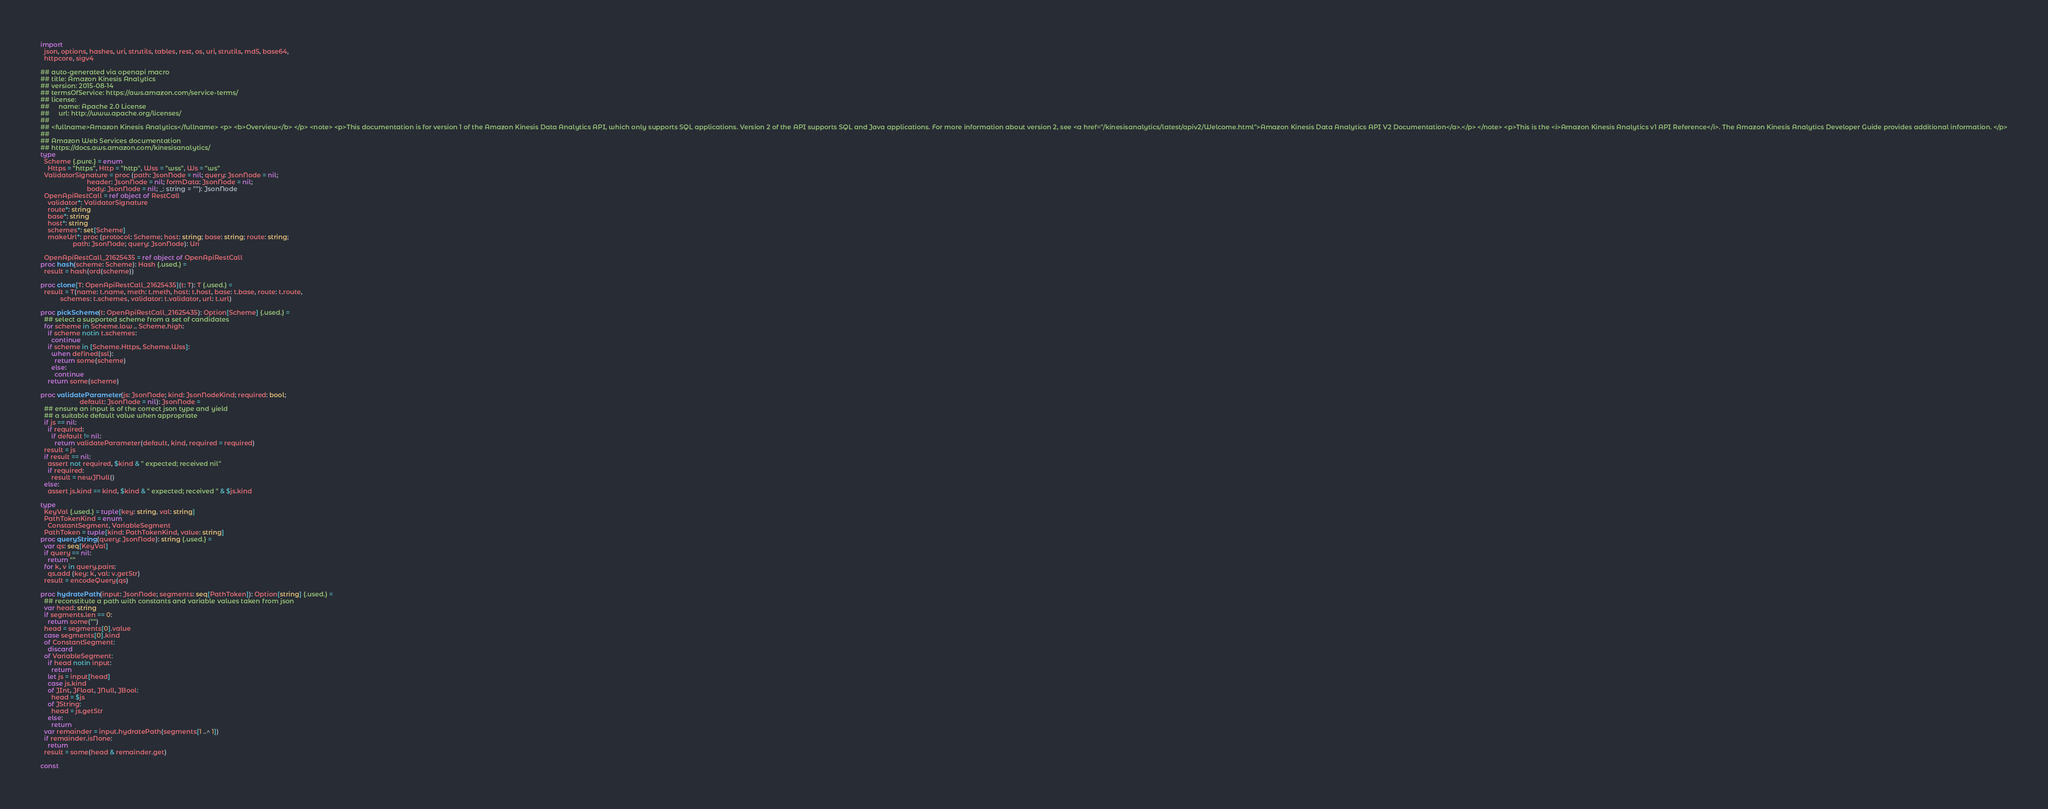Convert code to text. <code><loc_0><loc_0><loc_500><loc_500><_Nim_>
import
  json, options, hashes, uri, strutils, tables, rest, os, uri, strutils, md5, base64,
  httpcore, sigv4

## auto-generated via openapi macro
## title: Amazon Kinesis Analytics
## version: 2015-08-14
## termsOfService: https://aws.amazon.com/service-terms/
## license:
##     name: Apache 2.0 License
##     url: http://www.apache.org/licenses/
## 
## <fullname>Amazon Kinesis Analytics</fullname> <p> <b>Overview</b> </p> <note> <p>This documentation is for version 1 of the Amazon Kinesis Data Analytics API, which only supports SQL applications. Version 2 of the API supports SQL and Java applications. For more information about version 2, see <a href="/kinesisanalytics/latest/apiv2/Welcome.html">Amazon Kinesis Data Analytics API V2 Documentation</a>.</p> </note> <p>This is the <i>Amazon Kinesis Analytics v1 API Reference</i>. The Amazon Kinesis Analytics Developer Guide provides additional information. </p>
## 
## Amazon Web Services documentation
## https://docs.aws.amazon.com/kinesisanalytics/
type
  Scheme {.pure.} = enum
    Https = "https", Http = "http", Wss = "wss", Ws = "ws"
  ValidatorSignature = proc (path: JsonNode = nil; query: JsonNode = nil;
                          header: JsonNode = nil; formData: JsonNode = nil;
                          body: JsonNode = nil; _: string = ""): JsonNode
  OpenApiRestCall = ref object of RestCall
    validator*: ValidatorSignature
    route*: string
    base*: string
    host*: string
    schemes*: set[Scheme]
    makeUrl*: proc (protocol: Scheme; host: string; base: string; route: string;
                  path: JsonNode; query: JsonNode): Uri

  OpenApiRestCall_21625435 = ref object of OpenApiRestCall
proc hash(scheme: Scheme): Hash {.used.} =
  result = hash(ord(scheme))

proc clone[T: OpenApiRestCall_21625435](t: T): T {.used.} =
  result = T(name: t.name, meth: t.meth, host: t.host, base: t.base, route: t.route,
           schemes: t.schemes, validator: t.validator, url: t.url)

proc pickScheme(t: OpenApiRestCall_21625435): Option[Scheme] {.used.} =
  ## select a supported scheme from a set of candidates
  for scheme in Scheme.low .. Scheme.high:
    if scheme notin t.schemes:
      continue
    if scheme in [Scheme.Https, Scheme.Wss]:
      when defined(ssl):
        return some(scheme)
      else:
        continue
    return some(scheme)

proc validateParameter(js: JsonNode; kind: JsonNodeKind; required: bool;
                      default: JsonNode = nil): JsonNode =
  ## ensure an input is of the correct json type and yield
  ## a suitable default value when appropriate
  if js == nil:
    if required:
      if default != nil:
        return validateParameter(default, kind, required = required)
  result = js
  if result == nil:
    assert not required, $kind & " expected; received nil"
    if required:
      result = newJNull()
  else:
    assert js.kind == kind, $kind & " expected; received " & $js.kind

type
  KeyVal {.used.} = tuple[key: string, val: string]
  PathTokenKind = enum
    ConstantSegment, VariableSegment
  PathToken = tuple[kind: PathTokenKind, value: string]
proc queryString(query: JsonNode): string {.used.} =
  var qs: seq[KeyVal]
  if query == nil:
    return ""
  for k, v in query.pairs:
    qs.add (key: k, val: v.getStr)
  result = encodeQuery(qs)

proc hydratePath(input: JsonNode; segments: seq[PathToken]): Option[string] {.used.} =
  ## reconstitute a path with constants and variable values taken from json
  var head: string
  if segments.len == 0:
    return some("")
  head = segments[0].value
  case segments[0].kind
  of ConstantSegment:
    discard
  of VariableSegment:
    if head notin input:
      return
    let js = input[head]
    case js.kind
    of JInt, JFloat, JNull, JBool:
      head = $js
    of JString:
      head = js.getStr
    else:
      return
  var remainder = input.hydratePath(segments[1 ..^ 1])
  if remainder.isNone:
    return
  result = some(head & remainder.get)

const</code> 